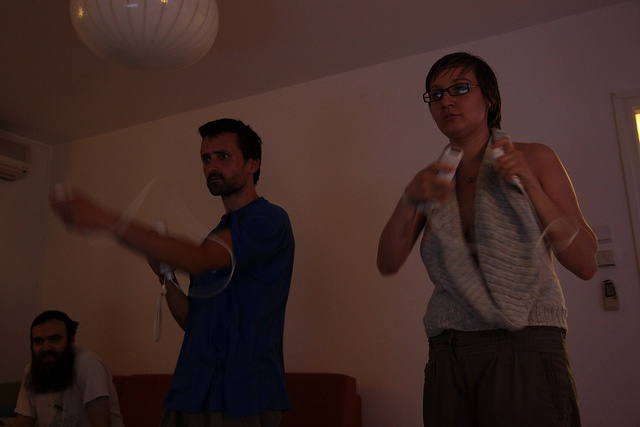Describe the objects in this image and their specific colors. I can see people in black, maroon, and brown tones, people in black and maroon tones, people in black tones, couch in black tones, and remote in black, maroon, and brown tones in this image. 